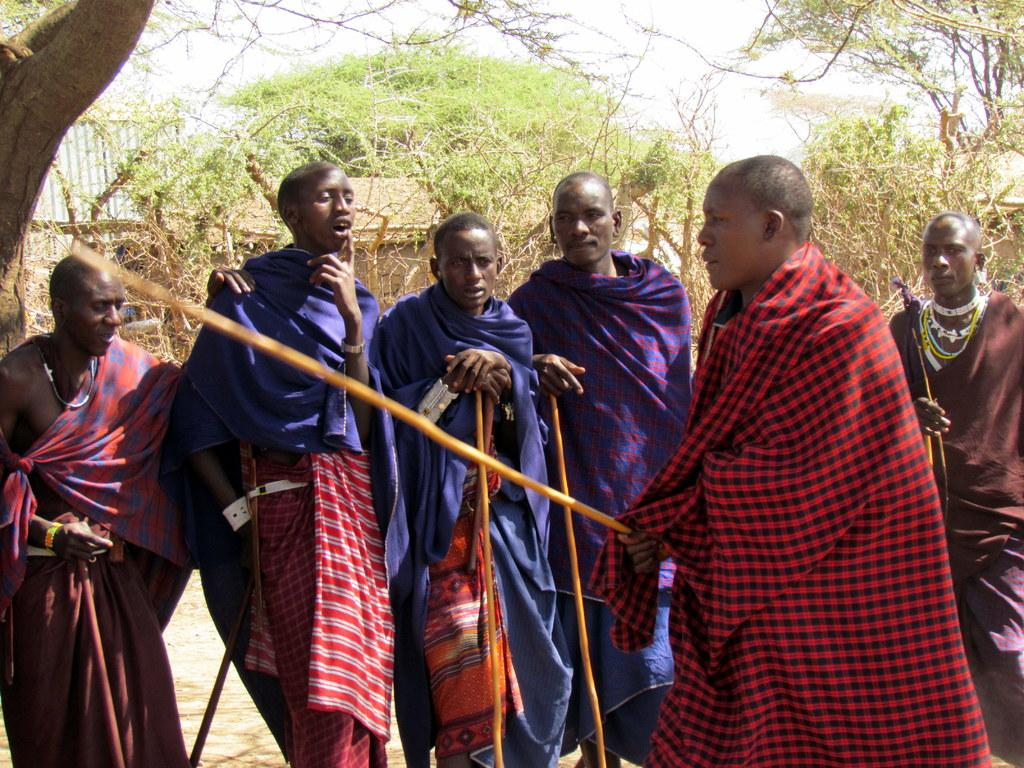What are the people in the image doing? The people in the image are standing on the ground. What are the people holding in their hands? The people are holding objects in the image. What type of structures can be seen in the image? There are houses in the image. What type of vegetation is present in the image? There are trees and plants on the ground in the image. What is visible at the top of the image? The sky is visible at the top of the image. What type of cake is being served on the ground in the image? There is no cake present in the image; the people are holding objects, but they are not cakes. 